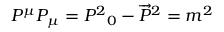Convert formula to latex. <formula><loc_0><loc_0><loc_500><loc_500>P ^ { \mu } P _ { \mu } = { P ^ { 2 } } _ { 0 } - { \overrightarrow { P } } ^ { 2 } = m ^ { 2 }</formula> 